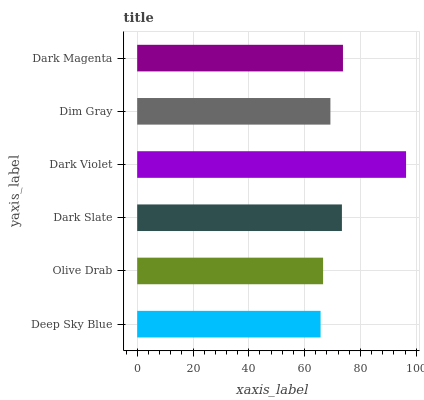Is Deep Sky Blue the minimum?
Answer yes or no. Yes. Is Dark Violet the maximum?
Answer yes or no. Yes. Is Olive Drab the minimum?
Answer yes or no. No. Is Olive Drab the maximum?
Answer yes or no. No. Is Olive Drab greater than Deep Sky Blue?
Answer yes or no. Yes. Is Deep Sky Blue less than Olive Drab?
Answer yes or no. Yes. Is Deep Sky Blue greater than Olive Drab?
Answer yes or no. No. Is Olive Drab less than Deep Sky Blue?
Answer yes or no. No. Is Dark Slate the high median?
Answer yes or no. Yes. Is Dim Gray the low median?
Answer yes or no. Yes. Is Deep Sky Blue the high median?
Answer yes or no. No. Is Olive Drab the low median?
Answer yes or no. No. 